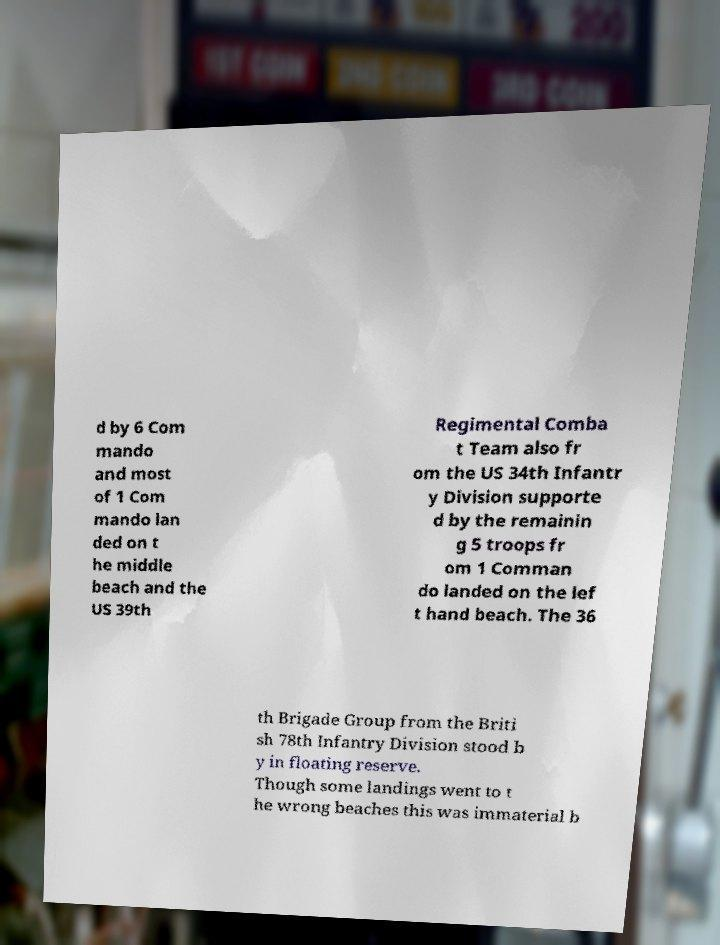For documentation purposes, I need the text within this image transcribed. Could you provide that? d by 6 Com mando and most of 1 Com mando lan ded on t he middle beach and the US 39th Regimental Comba t Team also fr om the US 34th Infantr y Division supporte d by the remainin g 5 troops fr om 1 Comman do landed on the lef t hand beach. The 36 th Brigade Group from the Briti sh 78th Infantry Division stood b y in floating reserve. Though some landings went to t he wrong beaches this was immaterial b 